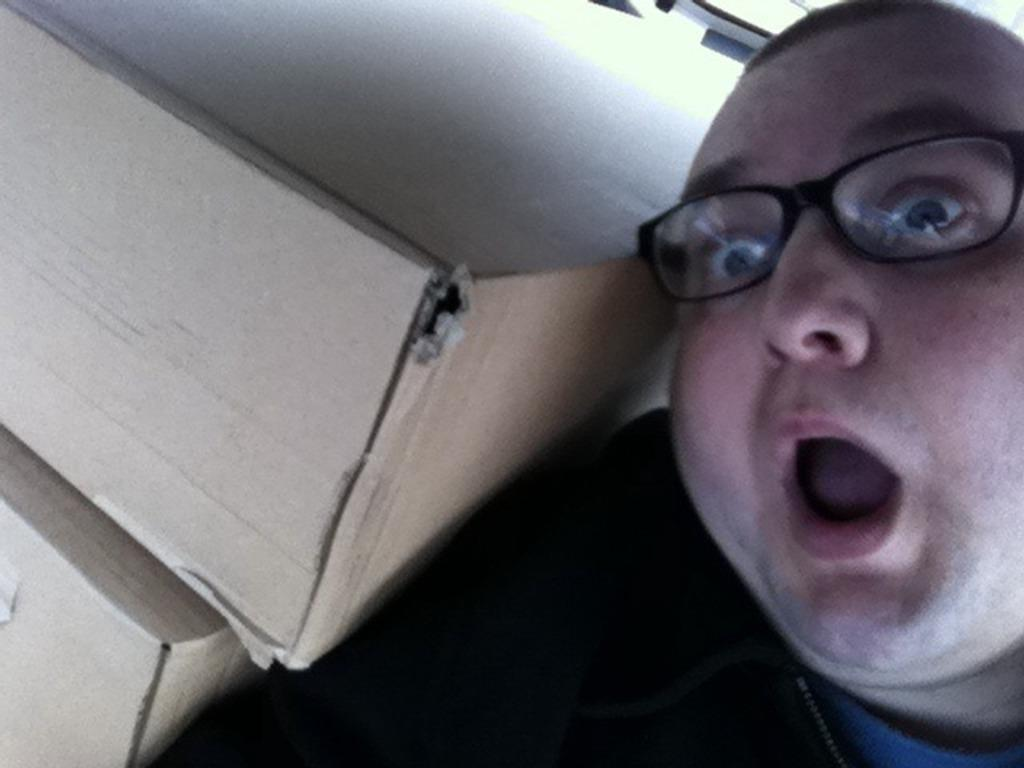Who is present in the image? There is a man in the image. What can be seen on the man's face? The man is wearing spectacles. What objects are located beside the man? There are two cardboard boxes beside the man. What type of ink is being used to write on the growth in the field? There is no ink, growth, or field present in the image. 